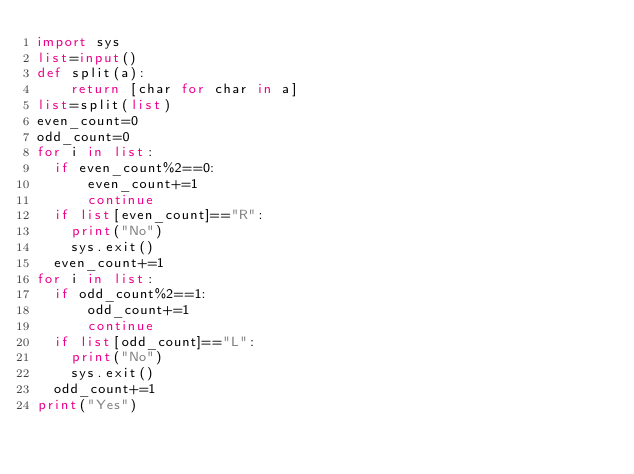<code> <loc_0><loc_0><loc_500><loc_500><_Python_>import sys
list=input()
def split(a): 
    return [char for char in a]
list=split(list)
even_count=0
odd_count=0
for i in list:
  if even_count%2==0:
      even_count+=1
      continue
  if list[even_count]=="R":
    print("No")
    sys.exit()
  even_count+=1
for i in list:
  if odd_count%2==1:
      odd_count+=1
      continue
  if list[odd_count]=="L":
    print("No")
    sys.exit()
  odd_count+=1
print("Yes")</code> 